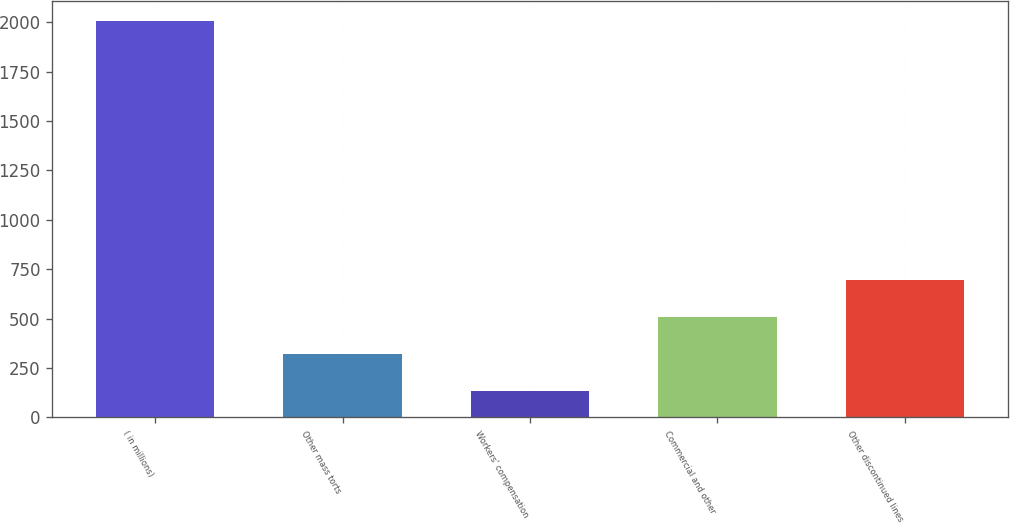Convert chart. <chart><loc_0><loc_0><loc_500><loc_500><bar_chart><fcel>( in millions)<fcel>Other mass torts<fcel>Workers' compensation<fcel>Commercial and other<fcel>Other discontinued lines<nl><fcel>2007<fcel>320.4<fcel>133<fcel>507.8<fcel>695.2<nl></chart> 